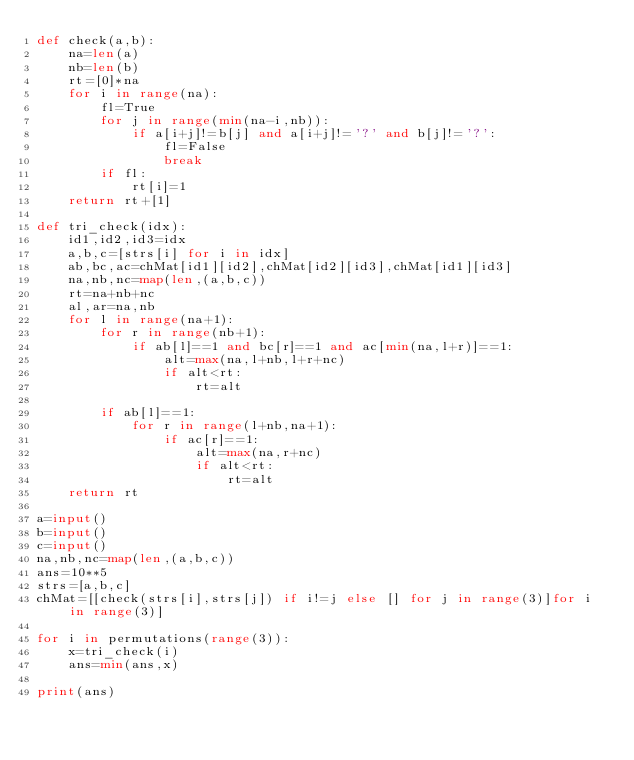Convert code to text. <code><loc_0><loc_0><loc_500><loc_500><_Python_>def check(a,b):
    na=len(a)
    nb=len(b)
    rt=[0]*na
    for i in range(na):
        fl=True
        for j in range(min(na-i,nb)):
            if a[i+j]!=b[j] and a[i+j]!='?' and b[j]!='?':
                fl=False
                break
        if fl:
            rt[i]=1
    return rt+[1]

def tri_check(idx):
    id1,id2,id3=idx
    a,b,c=[strs[i] for i in idx]
    ab,bc,ac=chMat[id1][id2],chMat[id2][id3],chMat[id1][id3]
    na,nb,nc=map(len,(a,b,c))
    rt=na+nb+nc
    al,ar=na,nb
    for l in range(na+1):
        for r in range(nb+1):
            if ab[l]==1 and bc[r]==1 and ac[min(na,l+r)]==1:
                alt=max(na,l+nb,l+r+nc)
                if alt<rt:
                    rt=alt

        if ab[l]==1:
            for r in range(l+nb,na+1):
                if ac[r]==1:
                    alt=max(na,r+nc)
                    if alt<rt:
                        rt=alt
    return rt
    
a=input()
b=input()
c=input()
na,nb,nc=map(len,(a,b,c))
ans=10**5
strs=[a,b,c]
chMat=[[check(strs[i],strs[j]) if i!=j else [] for j in range(3)]for i in range(3)]

for i in permutations(range(3)):
    x=tri_check(i)
    ans=min(ans,x)

print(ans)
</code> 